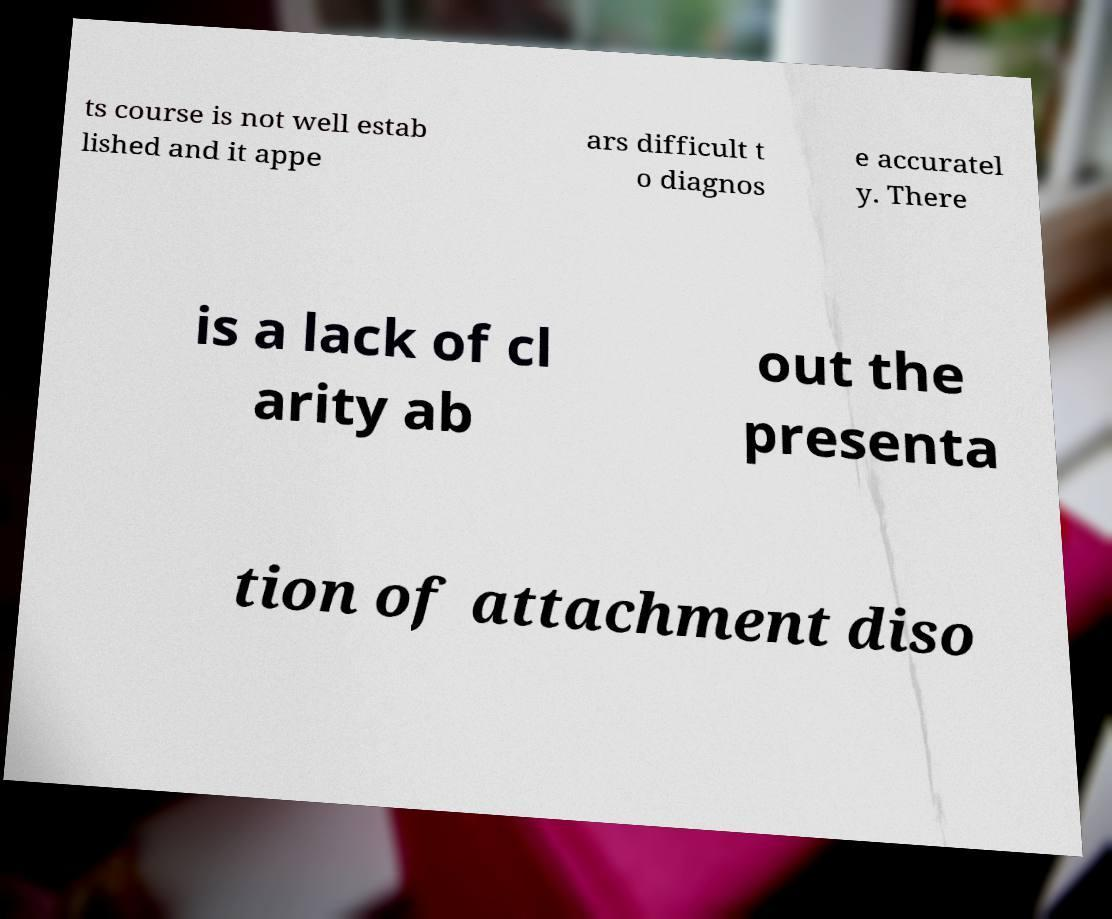Could you extract and type out the text from this image? ts course is not well estab lished and it appe ars difficult t o diagnos e accuratel y. There is a lack of cl arity ab out the presenta tion of attachment diso 